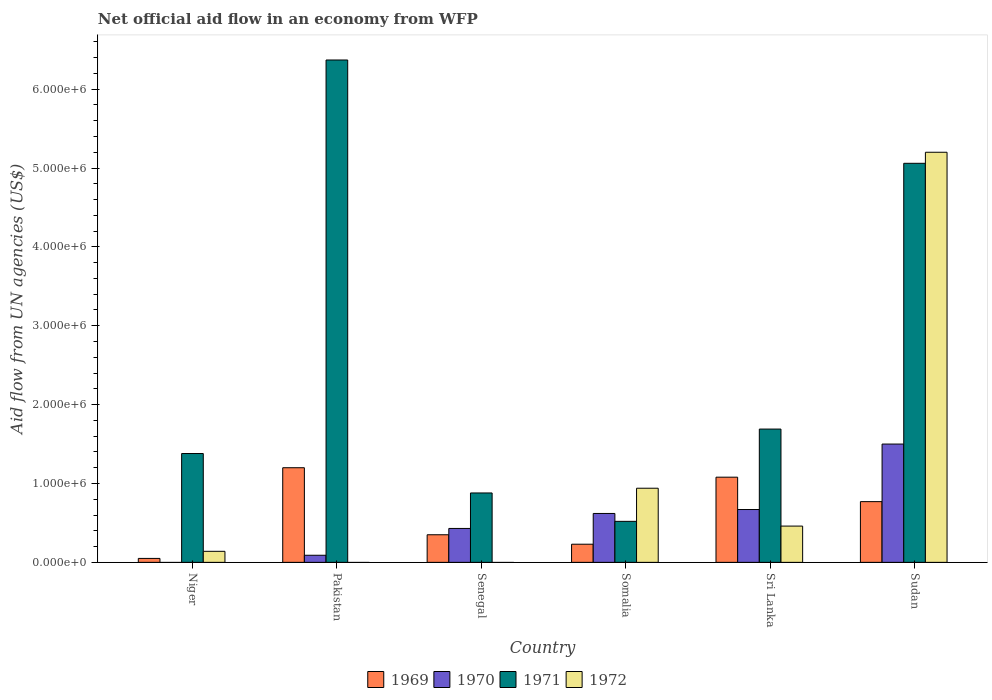How many different coloured bars are there?
Make the answer very short. 4. How many bars are there on the 2nd tick from the left?
Your answer should be compact. 3. In how many cases, is the number of bars for a given country not equal to the number of legend labels?
Provide a succinct answer. 3. What is the net official aid flow in 1971 in Pakistan?
Give a very brief answer. 6.37e+06. Across all countries, what is the maximum net official aid flow in 1969?
Provide a short and direct response. 1.20e+06. What is the total net official aid flow in 1971 in the graph?
Ensure brevity in your answer.  1.59e+07. What is the difference between the net official aid flow in 1969 in Niger and that in Pakistan?
Offer a very short reply. -1.15e+06. What is the difference between the net official aid flow in 1972 in Sri Lanka and the net official aid flow in 1969 in Somalia?
Give a very brief answer. 2.30e+05. What is the average net official aid flow in 1971 per country?
Provide a succinct answer. 2.65e+06. What is the difference between the net official aid flow of/in 1969 and net official aid flow of/in 1972 in Somalia?
Your answer should be compact. -7.10e+05. In how many countries, is the net official aid flow in 1971 greater than 1200000 US$?
Ensure brevity in your answer.  4. What is the ratio of the net official aid flow in 1971 in Niger to that in Sudan?
Offer a terse response. 0.27. Is the net official aid flow in 1972 in Niger less than that in Sri Lanka?
Make the answer very short. Yes. What is the difference between the highest and the second highest net official aid flow in 1969?
Make the answer very short. 4.30e+05. What is the difference between the highest and the lowest net official aid flow in 1969?
Provide a short and direct response. 1.15e+06. In how many countries, is the net official aid flow in 1971 greater than the average net official aid flow in 1971 taken over all countries?
Provide a short and direct response. 2. Is it the case that in every country, the sum of the net official aid flow in 1972 and net official aid flow in 1970 is greater than the net official aid flow in 1971?
Provide a short and direct response. No. Are all the bars in the graph horizontal?
Offer a very short reply. No. How many countries are there in the graph?
Give a very brief answer. 6. What is the difference between two consecutive major ticks on the Y-axis?
Provide a short and direct response. 1.00e+06. Does the graph contain any zero values?
Provide a succinct answer. Yes. Does the graph contain grids?
Ensure brevity in your answer.  No. Where does the legend appear in the graph?
Your answer should be very brief. Bottom center. How many legend labels are there?
Offer a terse response. 4. How are the legend labels stacked?
Provide a short and direct response. Horizontal. What is the title of the graph?
Provide a succinct answer. Net official aid flow in an economy from WFP. What is the label or title of the X-axis?
Give a very brief answer. Country. What is the label or title of the Y-axis?
Provide a succinct answer. Aid flow from UN agencies (US$). What is the Aid flow from UN agencies (US$) in 1969 in Niger?
Your answer should be compact. 5.00e+04. What is the Aid flow from UN agencies (US$) of 1971 in Niger?
Give a very brief answer. 1.38e+06. What is the Aid flow from UN agencies (US$) in 1969 in Pakistan?
Give a very brief answer. 1.20e+06. What is the Aid flow from UN agencies (US$) of 1971 in Pakistan?
Make the answer very short. 6.37e+06. What is the Aid flow from UN agencies (US$) of 1969 in Senegal?
Offer a terse response. 3.50e+05. What is the Aid flow from UN agencies (US$) in 1970 in Senegal?
Your answer should be very brief. 4.30e+05. What is the Aid flow from UN agencies (US$) of 1971 in Senegal?
Offer a terse response. 8.80e+05. What is the Aid flow from UN agencies (US$) in 1972 in Senegal?
Provide a short and direct response. 0. What is the Aid flow from UN agencies (US$) in 1969 in Somalia?
Your response must be concise. 2.30e+05. What is the Aid flow from UN agencies (US$) of 1970 in Somalia?
Your answer should be very brief. 6.20e+05. What is the Aid flow from UN agencies (US$) of 1971 in Somalia?
Provide a succinct answer. 5.20e+05. What is the Aid flow from UN agencies (US$) in 1972 in Somalia?
Give a very brief answer. 9.40e+05. What is the Aid flow from UN agencies (US$) in 1969 in Sri Lanka?
Your answer should be compact. 1.08e+06. What is the Aid flow from UN agencies (US$) of 1970 in Sri Lanka?
Ensure brevity in your answer.  6.70e+05. What is the Aid flow from UN agencies (US$) in 1971 in Sri Lanka?
Provide a short and direct response. 1.69e+06. What is the Aid flow from UN agencies (US$) of 1972 in Sri Lanka?
Your answer should be compact. 4.60e+05. What is the Aid flow from UN agencies (US$) in 1969 in Sudan?
Your response must be concise. 7.70e+05. What is the Aid flow from UN agencies (US$) in 1970 in Sudan?
Give a very brief answer. 1.50e+06. What is the Aid flow from UN agencies (US$) of 1971 in Sudan?
Ensure brevity in your answer.  5.06e+06. What is the Aid flow from UN agencies (US$) in 1972 in Sudan?
Your answer should be compact. 5.20e+06. Across all countries, what is the maximum Aid flow from UN agencies (US$) in 1969?
Your response must be concise. 1.20e+06. Across all countries, what is the maximum Aid flow from UN agencies (US$) in 1970?
Provide a succinct answer. 1.50e+06. Across all countries, what is the maximum Aid flow from UN agencies (US$) of 1971?
Make the answer very short. 6.37e+06. Across all countries, what is the maximum Aid flow from UN agencies (US$) of 1972?
Keep it short and to the point. 5.20e+06. Across all countries, what is the minimum Aid flow from UN agencies (US$) of 1969?
Ensure brevity in your answer.  5.00e+04. Across all countries, what is the minimum Aid flow from UN agencies (US$) in 1971?
Ensure brevity in your answer.  5.20e+05. Across all countries, what is the minimum Aid flow from UN agencies (US$) in 1972?
Ensure brevity in your answer.  0. What is the total Aid flow from UN agencies (US$) in 1969 in the graph?
Provide a short and direct response. 3.68e+06. What is the total Aid flow from UN agencies (US$) in 1970 in the graph?
Give a very brief answer. 3.31e+06. What is the total Aid flow from UN agencies (US$) in 1971 in the graph?
Offer a terse response. 1.59e+07. What is the total Aid flow from UN agencies (US$) of 1972 in the graph?
Provide a succinct answer. 6.74e+06. What is the difference between the Aid flow from UN agencies (US$) in 1969 in Niger and that in Pakistan?
Make the answer very short. -1.15e+06. What is the difference between the Aid flow from UN agencies (US$) of 1971 in Niger and that in Pakistan?
Ensure brevity in your answer.  -4.99e+06. What is the difference between the Aid flow from UN agencies (US$) of 1969 in Niger and that in Somalia?
Offer a terse response. -1.80e+05. What is the difference between the Aid flow from UN agencies (US$) in 1971 in Niger and that in Somalia?
Your response must be concise. 8.60e+05. What is the difference between the Aid flow from UN agencies (US$) of 1972 in Niger and that in Somalia?
Give a very brief answer. -8.00e+05. What is the difference between the Aid flow from UN agencies (US$) of 1969 in Niger and that in Sri Lanka?
Provide a short and direct response. -1.03e+06. What is the difference between the Aid flow from UN agencies (US$) in 1971 in Niger and that in Sri Lanka?
Offer a terse response. -3.10e+05. What is the difference between the Aid flow from UN agencies (US$) in 1972 in Niger and that in Sri Lanka?
Keep it short and to the point. -3.20e+05. What is the difference between the Aid flow from UN agencies (US$) of 1969 in Niger and that in Sudan?
Give a very brief answer. -7.20e+05. What is the difference between the Aid flow from UN agencies (US$) in 1971 in Niger and that in Sudan?
Your answer should be very brief. -3.68e+06. What is the difference between the Aid flow from UN agencies (US$) of 1972 in Niger and that in Sudan?
Offer a very short reply. -5.06e+06. What is the difference between the Aid flow from UN agencies (US$) in 1969 in Pakistan and that in Senegal?
Give a very brief answer. 8.50e+05. What is the difference between the Aid flow from UN agencies (US$) of 1970 in Pakistan and that in Senegal?
Your answer should be very brief. -3.40e+05. What is the difference between the Aid flow from UN agencies (US$) in 1971 in Pakistan and that in Senegal?
Your answer should be compact. 5.49e+06. What is the difference between the Aid flow from UN agencies (US$) of 1969 in Pakistan and that in Somalia?
Your answer should be very brief. 9.70e+05. What is the difference between the Aid flow from UN agencies (US$) of 1970 in Pakistan and that in Somalia?
Give a very brief answer. -5.30e+05. What is the difference between the Aid flow from UN agencies (US$) in 1971 in Pakistan and that in Somalia?
Provide a short and direct response. 5.85e+06. What is the difference between the Aid flow from UN agencies (US$) in 1969 in Pakistan and that in Sri Lanka?
Give a very brief answer. 1.20e+05. What is the difference between the Aid flow from UN agencies (US$) of 1970 in Pakistan and that in Sri Lanka?
Provide a succinct answer. -5.80e+05. What is the difference between the Aid flow from UN agencies (US$) of 1971 in Pakistan and that in Sri Lanka?
Your response must be concise. 4.68e+06. What is the difference between the Aid flow from UN agencies (US$) of 1969 in Pakistan and that in Sudan?
Keep it short and to the point. 4.30e+05. What is the difference between the Aid flow from UN agencies (US$) of 1970 in Pakistan and that in Sudan?
Your response must be concise. -1.41e+06. What is the difference between the Aid flow from UN agencies (US$) in 1971 in Pakistan and that in Sudan?
Your answer should be compact. 1.31e+06. What is the difference between the Aid flow from UN agencies (US$) in 1971 in Senegal and that in Somalia?
Your response must be concise. 3.60e+05. What is the difference between the Aid flow from UN agencies (US$) of 1969 in Senegal and that in Sri Lanka?
Your answer should be very brief. -7.30e+05. What is the difference between the Aid flow from UN agencies (US$) of 1970 in Senegal and that in Sri Lanka?
Ensure brevity in your answer.  -2.40e+05. What is the difference between the Aid flow from UN agencies (US$) in 1971 in Senegal and that in Sri Lanka?
Give a very brief answer. -8.10e+05. What is the difference between the Aid flow from UN agencies (US$) of 1969 in Senegal and that in Sudan?
Your answer should be very brief. -4.20e+05. What is the difference between the Aid flow from UN agencies (US$) in 1970 in Senegal and that in Sudan?
Your answer should be very brief. -1.07e+06. What is the difference between the Aid flow from UN agencies (US$) of 1971 in Senegal and that in Sudan?
Offer a very short reply. -4.18e+06. What is the difference between the Aid flow from UN agencies (US$) of 1969 in Somalia and that in Sri Lanka?
Provide a short and direct response. -8.50e+05. What is the difference between the Aid flow from UN agencies (US$) of 1970 in Somalia and that in Sri Lanka?
Your response must be concise. -5.00e+04. What is the difference between the Aid flow from UN agencies (US$) of 1971 in Somalia and that in Sri Lanka?
Your response must be concise. -1.17e+06. What is the difference between the Aid flow from UN agencies (US$) of 1969 in Somalia and that in Sudan?
Keep it short and to the point. -5.40e+05. What is the difference between the Aid flow from UN agencies (US$) of 1970 in Somalia and that in Sudan?
Provide a short and direct response. -8.80e+05. What is the difference between the Aid flow from UN agencies (US$) in 1971 in Somalia and that in Sudan?
Give a very brief answer. -4.54e+06. What is the difference between the Aid flow from UN agencies (US$) in 1972 in Somalia and that in Sudan?
Offer a very short reply. -4.26e+06. What is the difference between the Aid flow from UN agencies (US$) of 1969 in Sri Lanka and that in Sudan?
Keep it short and to the point. 3.10e+05. What is the difference between the Aid flow from UN agencies (US$) of 1970 in Sri Lanka and that in Sudan?
Provide a succinct answer. -8.30e+05. What is the difference between the Aid flow from UN agencies (US$) in 1971 in Sri Lanka and that in Sudan?
Provide a short and direct response. -3.37e+06. What is the difference between the Aid flow from UN agencies (US$) of 1972 in Sri Lanka and that in Sudan?
Make the answer very short. -4.74e+06. What is the difference between the Aid flow from UN agencies (US$) of 1969 in Niger and the Aid flow from UN agencies (US$) of 1971 in Pakistan?
Give a very brief answer. -6.32e+06. What is the difference between the Aid flow from UN agencies (US$) in 1969 in Niger and the Aid flow from UN agencies (US$) in 1970 in Senegal?
Make the answer very short. -3.80e+05. What is the difference between the Aid flow from UN agencies (US$) of 1969 in Niger and the Aid flow from UN agencies (US$) of 1971 in Senegal?
Offer a very short reply. -8.30e+05. What is the difference between the Aid flow from UN agencies (US$) of 1969 in Niger and the Aid flow from UN agencies (US$) of 1970 in Somalia?
Offer a terse response. -5.70e+05. What is the difference between the Aid flow from UN agencies (US$) in 1969 in Niger and the Aid flow from UN agencies (US$) in 1971 in Somalia?
Offer a terse response. -4.70e+05. What is the difference between the Aid flow from UN agencies (US$) of 1969 in Niger and the Aid flow from UN agencies (US$) of 1972 in Somalia?
Make the answer very short. -8.90e+05. What is the difference between the Aid flow from UN agencies (US$) of 1969 in Niger and the Aid flow from UN agencies (US$) of 1970 in Sri Lanka?
Give a very brief answer. -6.20e+05. What is the difference between the Aid flow from UN agencies (US$) of 1969 in Niger and the Aid flow from UN agencies (US$) of 1971 in Sri Lanka?
Ensure brevity in your answer.  -1.64e+06. What is the difference between the Aid flow from UN agencies (US$) in 1969 in Niger and the Aid flow from UN agencies (US$) in 1972 in Sri Lanka?
Provide a succinct answer. -4.10e+05. What is the difference between the Aid flow from UN agencies (US$) of 1971 in Niger and the Aid flow from UN agencies (US$) of 1972 in Sri Lanka?
Your answer should be compact. 9.20e+05. What is the difference between the Aid flow from UN agencies (US$) of 1969 in Niger and the Aid flow from UN agencies (US$) of 1970 in Sudan?
Provide a succinct answer. -1.45e+06. What is the difference between the Aid flow from UN agencies (US$) of 1969 in Niger and the Aid flow from UN agencies (US$) of 1971 in Sudan?
Your response must be concise. -5.01e+06. What is the difference between the Aid flow from UN agencies (US$) of 1969 in Niger and the Aid flow from UN agencies (US$) of 1972 in Sudan?
Your answer should be compact. -5.15e+06. What is the difference between the Aid flow from UN agencies (US$) in 1971 in Niger and the Aid flow from UN agencies (US$) in 1972 in Sudan?
Provide a succinct answer. -3.82e+06. What is the difference between the Aid flow from UN agencies (US$) in 1969 in Pakistan and the Aid flow from UN agencies (US$) in 1970 in Senegal?
Offer a terse response. 7.70e+05. What is the difference between the Aid flow from UN agencies (US$) of 1970 in Pakistan and the Aid flow from UN agencies (US$) of 1971 in Senegal?
Ensure brevity in your answer.  -7.90e+05. What is the difference between the Aid flow from UN agencies (US$) of 1969 in Pakistan and the Aid flow from UN agencies (US$) of 1970 in Somalia?
Your answer should be very brief. 5.80e+05. What is the difference between the Aid flow from UN agencies (US$) in 1969 in Pakistan and the Aid flow from UN agencies (US$) in 1971 in Somalia?
Give a very brief answer. 6.80e+05. What is the difference between the Aid flow from UN agencies (US$) in 1969 in Pakistan and the Aid flow from UN agencies (US$) in 1972 in Somalia?
Offer a terse response. 2.60e+05. What is the difference between the Aid flow from UN agencies (US$) in 1970 in Pakistan and the Aid flow from UN agencies (US$) in 1971 in Somalia?
Keep it short and to the point. -4.30e+05. What is the difference between the Aid flow from UN agencies (US$) in 1970 in Pakistan and the Aid flow from UN agencies (US$) in 1972 in Somalia?
Offer a very short reply. -8.50e+05. What is the difference between the Aid flow from UN agencies (US$) of 1971 in Pakistan and the Aid flow from UN agencies (US$) of 1972 in Somalia?
Make the answer very short. 5.43e+06. What is the difference between the Aid flow from UN agencies (US$) in 1969 in Pakistan and the Aid flow from UN agencies (US$) in 1970 in Sri Lanka?
Ensure brevity in your answer.  5.30e+05. What is the difference between the Aid flow from UN agencies (US$) of 1969 in Pakistan and the Aid flow from UN agencies (US$) of 1971 in Sri Lanka?
Your answer should be compact. -4.90e+05. What is the difference between the Aid flow from UN agencies (US$) in 1969 in Pakistan and the Aid flow from UN agencies (US$) in 1972 in Sri Lanka?
Your response must be concise. 7.40e+05. What is the difference between the Aid flow from UN agencies (US$) of 1970 in Pakistan and the Aid flow from UN agencies (US$) of 1971 in Sri Lanka?
Ensure brevity in your answer.  -1.60e+06. What is the difference between the Aid flow from UN agencies (US$) of 1970 in Pakistan and the Aid flow from UN agencies (US$) of 1972 in Sri Lanka?
Give a very brief answer. -3.70e+05. What is the difference between the Aid flow from UN agencies (US$) in 1971 in Pakistan and the Aid flow from UN agencies (US$) in 1972 in Sri Lanka?
Provide a succinct answer. 5.91e+06. What is the difference between the Aid flow from UN agencies (US$) of 1969 in Pakistan and the Aid flow from UN agencies (US$) of 1971 in Sudan?
Ensure brevity in your answer.  -3.86e+06. What is the difference between the Aid flow from UN agencies (US$) in 1970 in Pakistan and the Aid flow from UN agencies (US$) in 1971 in Sudan?
Offer a very short reply. -4.97e+06. What is the difference between the Aid flow from UN agencies (US$) of 1970 in Pakistan and the Aid flow from UN agencies (US$) of 1972 in Sudan?
Give a very brief answer. -5.11e+06. What is the difference between the Aid flow from UN agencies (US$) in 1971 in Pakistan and the Aid flow from UN agencies (US$) in 1972 in Sudan?
Offer a very short reply. 1.17e+06. What is the difference between the Aid flow from UN agencies (US$) in 1969 in Senegal and the Aid flow from UN agencies (US$) in 1972 in Somalia?
Ensure brevity in your answer.  -5.90e+05. What is the difference between the Aid flow from UN agencies (US$) of 1970 in Senegal and the Aid flow from UN agencies (US$) of 1971 in Somalia?
Ensure brevity in your answer.  -9.00e+04. What is the difference between the Aid flow from UN agencies (US$) in 1970 in Senegal and the Aid flow from UN agencies (US$) in 1972 in Somalia?
Make the answer very short. -5.10e+05. What is the difference between the Aid flow from UN agencies (US$) in 1971 in Senegal and the Aid flow from UN agencies (US$) in 1972 in Somalia?
Ensure brevity in your answer.  -6.00e+04. What is the difference between the Aid flow from UN agencies (US$) in 1969 in Senegal and the Aid flow from UN agencies (US$) in 1970 in Sri Lanka?
Make the answer very short. -3.20e+05. What is the difference between the Aid flow from UN agencies (US$) in 1969 in Senegal and the Aid flow from UN agencies (US$) in 1971 in Sri Lanka?
Your answer should be very brief. -1.34e+06. What is the difference between the Aid flow from UN agencies (US$) in 1970 in Senegal and the Aid flow from UN agencies (US$) in 1971 in Sri Lanka?
Provide a short and direct response. -1.26e+06. What is the difference between the Aid flow from UN agencies (US$) in 1970 in Senegal and the Aid flow from UN agencies (US$) in 1972 in Sri Lanka?
Provide a succinct answer. -3.00e+04. What is the difference between the Aid flow from UN agencies (US$) of 1969 in Senegal and the Aid flow from UN agencies (US$) of 1970 in Sudan?
Keep it short and to the point. -1.15e+06. What is the difference between the Aid flow from UN agencies (US$) in 1969 in Senegal and the Aid flow from UN agencies (US$) in 1971 in Sudan?
Keep it short and to the point. -4.71e+06. What is the difference between the Aid flow from UN agencies (US$) of 1969 in Senegal and the Aid flow from UN agencies (US$) of 1972 in Sudan?
Give a very brief answer. -4.85e+06. What is the difference between the Aid flow from UN agencies (US$) in 1970 in Senegal and the Aid flow from UN agencies (US$) in 1971 in Sudan?
Your answer should be compact. -4.63e+06. What is the difference between the Aid flow from UN agencies (US$) in 1970 in Senegal and the Aid flow from UN agencies (US$) in 1972 in Sudan?
Your response must be concise. -4.77e+06. What is the difference between the Aid flow from UN agencies (US$) of 1971 in Senegal and the Aid flow from UN agencies (US$) of 1972 in Sudan?
Offer a terse response. -4.32e+06. What is the difference between the Aid flow from UN agencies (US$) of 1969 in Somalia and the Aid flow from UN agencies (US$) of 1970 in Sri Lanka?
Give a very brief answer. -4.40e+05. What is the difference between the Aid flow from UN agencies (US$) in 1969 in Somalia and the Aid flow from UN agencies (US$) in 1971 in Sri Lanka?
Your answer should be very brief. -1.46e+06. What is the difference between the Aid flow from UN agencies (US$) in 1969 in Somalia and the Aid flow from UN agencies (US$) in 1972 in Sri Lanka?
Offer a terse response. -2.30e+05. What is the difference between the Aid flow from UN agencies (US$) of 1970 in Somalia and the Aid flow from UN agencies (US$) of 1971 in Sri Lanka?
Ensure brevity in your answer.  -1.07e+06. What is the difference between the Aid flow from UN agencies (US$) of 1970 in Somalia and the Aid flow from UN agencies (US$) of 1972 in Sri Lanka?
Your answer should be compact. 1.60e+05. What is the difference between the Aid flow from UN agencies (US$) of 1971 in Somalia and the Aid flow from UN agencies (US$) of 1972 in Sri Lanka?
Keep it short and to the point. 6.00e+04. What is the difference between the Aid flow from UN agencies (US$) in 1969 in Somalia and the Aid flow from UN agencies (US$) in 1970 in Sudan?
Offer a very short reply. -1.27e+06. What is the difference between the Aid flow from UN agencies (US$) of 1969 in Somalia and the Aid flow from UN agencies (US$) of 1971 in Sudan?
Give a very brief answer. -4.83e+06. What is the difference between the Aid flow from UN agencies (US$) in 1969 in Somalia and the Aid flow from UN agencies (US$) in 1972 in Sudan?
Provide a succinct answer. -4.97e+06. What is the difference between the Aid flow from UN agencies (US$) in 1970 in Somalia and the Aid flow from UN agencies (US$) in 1971 in Sudan?
Ensure brevity in your answer.  -4.44e+06. What is the difference between the Aid flow from UN agencies (US$) of 1970 in Somalia and the Aid flow from UN agencies (US$) of 1972 in Sudan?
Keep it short and to the point. -4.58e+06. What is the difference between the Aid flow from UN agencies (US$) in 1971 in Somalia and the Aid flow from UN agencies (US$) in 1972 in Sudan?
Offer a very short reply. -4.68e+06. What is the difference between the Aid flow from UN agencies (US$) of 1969 in Sri Lanka and the Aid flow from UN agencies (US$) of 1970 in Sudan?
Your response must be concise. -4.20e+05. What is the difference between the Aid flow from UN agencies (US$) of 1969 in Sri Lanka and the Aid flow from UN agencies (US$) of 1971 in Sudan?
Keep it short and to the point. -3.98e+06. What is the difference between the Aid flow from UN agencies (US$) of 1969 in Sri Lanka and the Aid flow from UN agencies (US$) of 1972 in Sudan?
Give a very brief answer. -4.12e+06. What is the difference between the Aid flow from UN agencies (US$) in 1970 in Sri Lanka and the Aid flow from UN agencies (US$) in 1971 in Sudan?
Provide a succinct answer. -4.39e+06. What is the difference between the Aid flow from UN agencies (US$) in 1970 in Sri Lanka and the Aid flow from UN agencies (US$) in 1972 in Sudan?
Your response must be concise. -4.53e+06. What is the difference between the Aid flow from UN agencies (US$) in 1971 in Sri Lanka and the Aid flow from UN agencies (US$) in 1972 in Sudan?
Provide a short and direct response. -3.51e+06. What is the average Aid flow from UN agencies (US$) in 1969 per country?
Your answer should be compact. 6.13e+05. What is the average Aid flow from UN agencies (US$) in 1970 per country?
Your answer should be compact. 5.52e+05. What is the average Aid flow from UN agencies (US$) of 1971 per country?
Give a very brief answer. 2.65e+06. What is the average Aid flow from UN agencies (US$) in 1972 per country?
Give a very brief answer. 1.12e+06. What is the difference between the Aid flow from UN agencies (US$) in 1969 and Aid flow from UN agencies (US$) in 1971 in Niger?
Make the answer very short. -1.33e+06. What is the difference between the Aid flow from UN agencies (US$) in 1969 and Aid flow from UN agencies (US$) in 1972 in Niger?
Give a very brief answer. -9.00e+04. What is the difference between the Aid flow from UN agencies (US$) in 1971 and Aid flow from UN agencies (US$) in 1972 in Niger?
Keep it short and to the point. 1.24e+06. What is the difference between the Aid flow from UN agencies (US$) of 1969 and Aid flow from UN agencies (US$) of 1970 in Pakistan?
Provide a succinct answer. 1.11e+06. What is the difference between the Aid flow from UN agencies (US$) in 1969 and Aid flow from UN agencies (US$) in 1971 in Pakistan?
Offer a very short reply. -5.17e+06. What is the difference between the Aid flow from UN agencies (US$) in 1970 and Aid flow from UN agencies (US$) in 1971 in Pakistan?
Provide a short and direct response. -6.28e+06. What is the difference between the Aid flow from UN agencies (US$) of 1969 and Aid flow from UN agencies (US$) of 1971 in Senegal?
Your response must be concise. -5.30e+05. What is the difference between the Aid flow from UN agencies (US$) in 1970 and Aid flow from UN agencies (US$) in 1971 in Senegal?
Provide a succinct answer. -4.50e+05. What is the difference between the Aid flow from UN agencies (US$) of 1969 and Aid flow from UN agencies (US$) of 1970 in Somalia?
Your answer should be compact. -3.90e+05. What is the difference between the Aid flow from UN agencies (US$) of 1969 and Aid flow from UN agencies (US$) of 1971 in Somalia?
Your answer should be very brief. -2.90e+05. What is the difference between the Aid flow from UN agencies (US$) in 1969 and Aid flow from UN agencies (US$) in 1972 in Somalia?
Keep it short and to the point. -7.10e+05. What is the difference between the Aid flow from UN agencies (US$) of 1970 and Aid flow from UN agencies (US$) of 1972 in Somalia?
Keep it short and to the point. -3.20e+05. What is the difference between the Aid flow from UN agencies (US$) of 1971 and Aid flow from UN agencies (US$) of 1972 in Somalia?
Ensure brevity in your answer.  -4.20e+05. What is the difference between the Aid flow from UN agencies (US$) in 1969 and Aid flow from UN agencies (US$) in 1970 in Sri Lanka?
Provide a short and direct response. 4.10e+05. What is the difference between the Aid flow from UN agencies (US$) of 1969 and Aid flow from UN agencies (US$) of 1971 in Sri Lanka?
Your answer should be very brief. -6.10e+05. What is the difference between the Aid flow from UN agencies (US$) in 1969 and Aid flow from UN agencies (US$) in 1972 in Sri Lanka?
Give a very brief answer. 6.20e+05. What is the difference between the Aid flow from UN agencies (US$) of 1970 and Aid flow from UN agencies (US$) of 1971 in Sri Lanka?
Offer a terse response. -1.02e+06. What is the difference between the Aid flow from UN agencies (US$) in 1971 and Aid flow from UN agencies (US$) in 1972 in Sri Lanka?
Give a very brief answer. 1.23e+06. What is the difference between the Aid flow from UN agencies (US$) in 1969 and Aid flow from UN agencies (US$) in 1970 in Sudan?
Keep it short and to the point. -7.30e+05. What is the difference between the Aid flow from UN agencies (US$) of 1969 and Aid flow from UN agencies (US$) of 1971 in Sudan?
Keep it short and to the point. -4.29e+06. What is the difference between the Aid flow from UN agencies (US$) of 1969 and Aid flow from UN agencies (US$) of 1972 in Sudan?
Ensure brevity in your answer.  -4.43e+06. What is the difference between the Aid flow from UN agencies (US$) in 1970 and Aid flow from UN agencies (US$) in 1971 in Sudan?
Give a very brief answer. -3.56e+06. What is the difference between the Aid flow from UN agencies (US$) in 1970 and Aid flow from UN agencies (US$) in 1972 in Sudan?
Provide a short and direct response. -3.70e+06. What is the difference between the Aid flow from UN agencies (US$) in 1971 and Aid flow from UN agencies (US$) in 1972 in Sudan?
Your response must be concise. -1.40e+05. What is the ratio of the Aid flow from UN agencies (US$) in 1969 in Niger to that in Pakistan?
Make the answer very short. 0.04. What is the ratio of the Aid flow from UN agencies (US$) of 1971 in Niger to that in Pakistan?
Offer a terse response. 0.22. What is the ratio of the Aid flow from UN agencies (US$) in 1969 in Niger to that in Senegal?
Your response must be concise. 0.14. What is the ratio of the Aid flow from UN agencies (US$) in 1971 in Niger to that in Senegal?
Make the answer very short. 1.57. What is the ratio of the Aid flow from UN agencies (US$) of 1969 in Niger to that in Somalia?
Give a very brief answer. 0.22. What is the ratio of the Aid flow from UN agencies (US$) of 1971 in Niger to that in Somalia?
Provide a succinct answer. 2.65. What is the ratio of the Aid flow from UN agencies (US$) of 1972 in Niger to that in Somalia?
Provide a short and direct response. 0.15. What is the ratio of the Aid flow from UN agencies (US$) in 1969 in Niger to that in Sri Lanka?
Provide a succinct answer. 0.05. What is the ratio of the Aid flow from UN agencies (US$) in 1971 in Niger to that in Sri Lanka?
Offer a terse response. 0.82. What is the ratio of the Aid flow from UN agencies (US$) of 1972 in Niger to that in Sri Lanka?
Give a very brief answer. 0.3. What is the ratio of the Aid flow from UN agencies (US$) in 1969 in Niger to that in Sudan?
Make the answer very short. 0.06. What is the ratio of the Aid flow from UN agencies (US$) in 1971 in Niger to that in Sudan?
Offer a very short reply. 0.27. What is the ratio of the Aid flow from UN agencies (US$) of 1972 in Niger to that in Sudan?
Ensure brevity in your answer.  0.03. What is the ratio of the Aid flow from UN agencies (US$) of 1969 in Pakistan to that in Senegal?
Your response must be concise. 3.43. What is the ratio of the Aid flow from UN agencies (US$) in 1970 in Pakistan to that in Senegal?
Provide a succinct answer. 0.21. What is the ratio of the Aid flow from UN agencies (US$) in 1971 in Pakistan to that in Senegal?
Ensure brevity in your answer.  7.24. What is the ratio of the Aid flow from UN agencies (US$) of 1969 in Pakistan to that in Somalia?
Your answer should be compact. 5.22. What is the ratio of the Aid flow from UN agencies (US$) in 1970 in Pakistan to that in Somalia?
Make the answer very short. 0.15. What is the ratio of the Aid flow from UN agencies (US$) of 1971 in Pakistan to that in Somalia?
Make the answer very short. 12.25. What is the ratio of the Aid flow from UN agencies (US$) of 1970 in Pakistan to that in Sri Lanka?
Your answer should be compact. 0.13. What is the ratio of the Aid flow from UN agencies (US$) in 1971 in Pakistan to that in Sri Lanka?
Offer a very short reply. 3.77. What is the ratio of the Aid flow from UN agencies (US$) of 1969 in Pakistan to that in Sudan?
Your response must be concise. 1.56. What is the ratio of the Aid flow from UN agencies (US$) in 1970 in Pakistan to that in Sudan?
Your response must be concise. 0.06. What is the ratio of the Aid flow from UN agencies (US$) of 1971 in Pakistan to that in Sudan?
Offer a terse response. 1.26. What is the ratio of the Aid flow from UN agencies (US$) in 1969 in Senegal to that in Somalia?
Provide a short and direct response. 1.52. What is the ratio of the Aid flow from UN agencies (US$) of 1970 in Senegal to that in Somalia?
Give a very brief answer. 0.69. What is the ratio of the Aid flow from UN agencies (US$) of 1971 in Senegal to that in Somalia?
Provide a succinct answer. 1.69. What is the ratio of the Aid flow from UN agencies (US$) in 1969 in Senegal to that in Sri Lanka?
Make the answer very short. 0.32. What is the ratio of the Aid flow from UN agencies (US$) of 1970 in Senegal to that in Sri Lanka?
Provide a short and direct response. 0.64. What is the ratio of the Aid flow from UN agencies (US$) in 1971 in Senegal to that in Sri Lanka?
Make the answer very short. 0.52. What is the ratio of the Aid flow from UN agencies (US$) in 1969 in Senegal to that in Sudan?
Give a very brief answer. 0.45. What is the ratio of the Aid flow from UN agencies (US$) of 1970 in Senegal to that in Sudan?
Your answer should be very brief. 0.29. What is the ratio of the Aid flow from UN agencies (US$) in 1971 in Senegal to that in Sudan?
Provide a succinct answer. 0.17. What is the ratio of the Aid flow from UN agencies (US$) of 1969 in Somalia to that in Sri Lanka?
Your answer should be compact. 0.21. What is the ratio of the Aid flow from UN agencies (US$) in 1970 in Somalia to that in Sri Lanka?
Give a very brief answer. 0.93. What is the ratio of the Aid flow from UN agencies (US$) of 1971 in Somalia to that in Sri Lanka?
Your answer should be compact. 0.31. What is the ratio of the Aid flow from UN agencies (US$) in 1972 in Somalia to that in Sri Lanka?
Provide a succinct answer. 2.04. What is the ratio of the Aid flow from UN agencies (US$) in 1969 in Somalia to that in Sudan?
Your answer should be very brief. 0.3. What is the ratio of the Aid flow from UN agencies (US$) of 1970 in Somalia to that in Sudan?
Offer a very short reply. 0.41. What is the ratio of the Aid flow from UN agencies (US$) of 1971 in Somalia to that in Sudan?
Your answer should be compact. 0.1. What is the ratio of the Aid flow from UN agencies (US$) in 1972 in Somalia to that in Sudan?
Give a very brief answer. 0.18. What is the ratio of the Aid flow from UN agencies (US$) in 1969 in Sri Lanka to that in Sudan?
Provide a short and direct response. 1.4. What is the ratio of the Aid flow from UN agencies (US$) of 1970 in Sri Lanka to that in Sudan?
Offer a terse response. 0.45. What is the ratio of the Aid flow from UN agencies (US$) of 1971 in Sri Lanka to that in Sudan?
Your response must be concise. 0.33. What is the ratio of the Aid flow from UN agencies (US$) in 1972 in Sri Lanka to that in Sudan?
Your response must be concise. 0.09. What is the difference between the highest and the second highest Aid flow from UN agencies (US$) in 1969?
Your response must be concise. 1.20e+05. What is the difference between the highest and the second highest Aid flow from UN agencies (US$) in 1970?
Offer a very short reply. 8.30e+05. What is the difference between the highest and the second highest Aid flow from UN agencies (US$) of 1971?
Your answer should be compact. 1.31e+06. What is the difference between the highest and the second highest Aid flow from UN agencies (US$) in 1972?
Keep it short and to the point. 4.26e+06. What is the difference between the highest and the lowest Aid flow from UN agencies (US$) of 1969?
Your answer should be very brief. 1.15e+06. What is the difference between the highest and the lowest Aid flow from UN agencies (US$) of 1970?
Your answer should be very brief. 1.50e+06. What is the difference between the highest and the lowest Aid flow from UN agencies (US$) in 1971?
Keep it short and to the point. 5.85e+06. What is the difference between the highest and the lowest Aid flow from UN agencies (US$) of 1972?
Keep it short and to the point. 5.20e+06. 